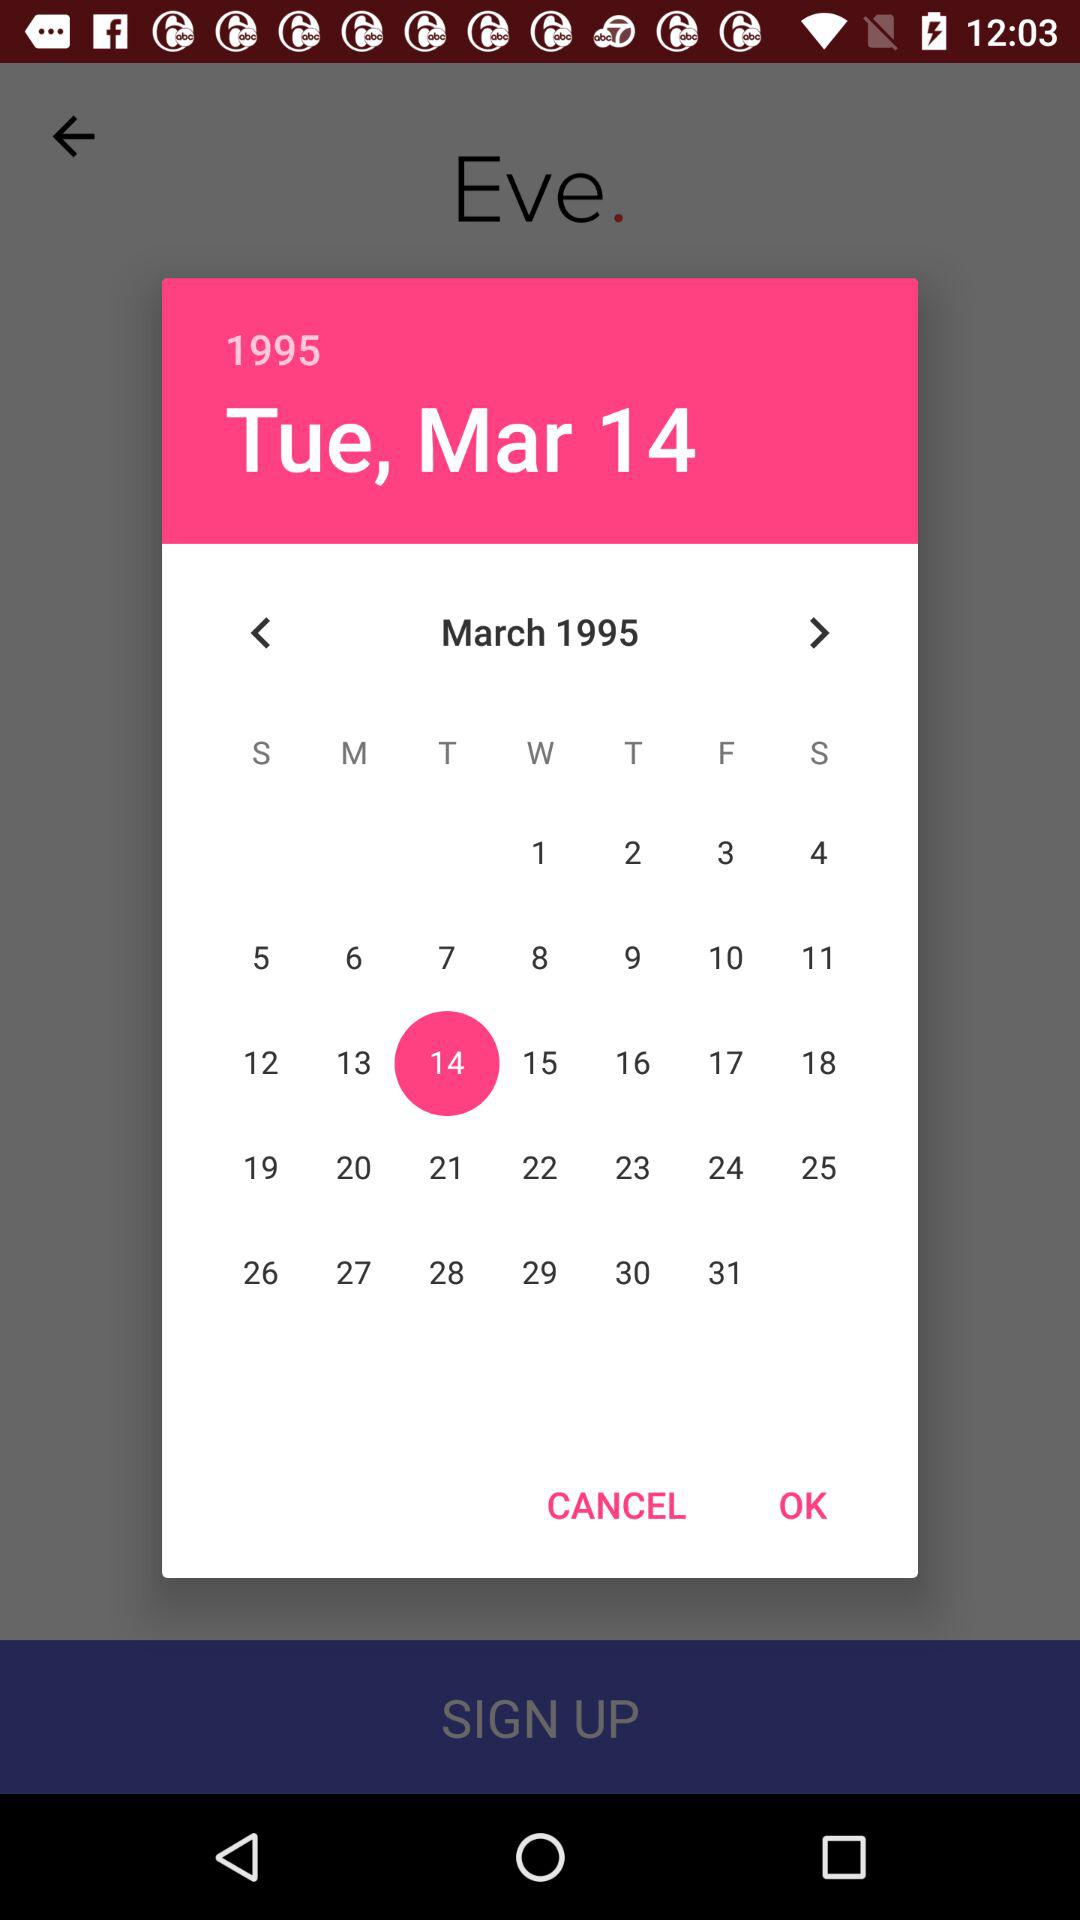What is the day on March 14, 1995? The day is Tuesday on March 14, 1995. 